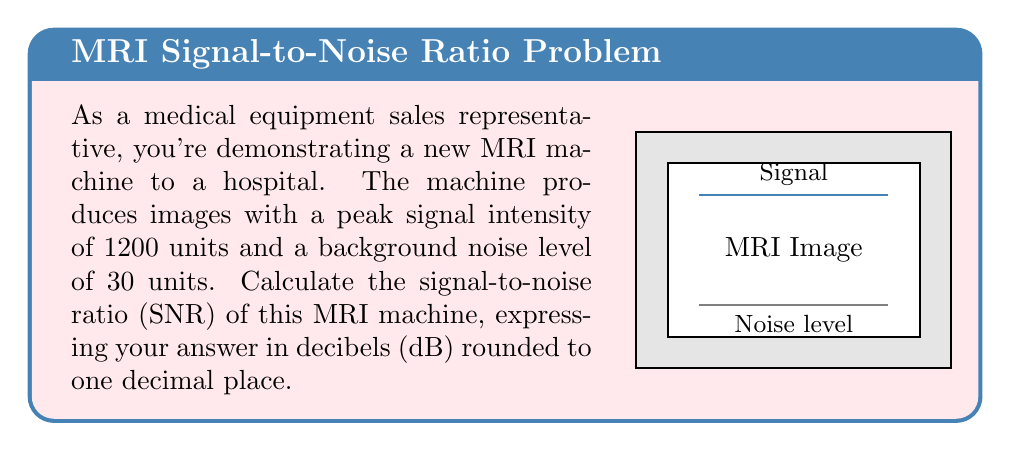Could you help me with this problem? To solve this problem, we'll follow these steps:

1) The signal-to-noise ratio (SNR) is defined as the ratio of the signal power to the noise power. In this case, we're given intensity values, which are proportional to power.

2) The formula for SNR in decibels is:

   $$SNR_{dB} = 10 \log_{10}\left(\frac{Signal}{Noise}\right)^2$$

3) Let's plug in our values:
   Signal = 1200 units
   Noise = 30 units

   $$SNR_{dB} = 10 \log_{10}\left(\frac{1200}{30}\right)^2$$

4) Simplify inside the parentheses:

   $$SNR_{dB} = 10 \log_{10}(40^2)$$

5) Calculate the square:

   $$SNR_{dB} = 10 \log_{10}(1600)$$

6) Use a calculator or logarithm tables to compute:

   $$SNR_{dB} = 10 * 3.2041...$$

7) Multiply:

   $$SNR_{dB} = 32.041...$$

8) Round to one decimal place:

   $$SNR_{dB} \approx 32.0 \text{ dB}$$
Answer: 32.0 dB 